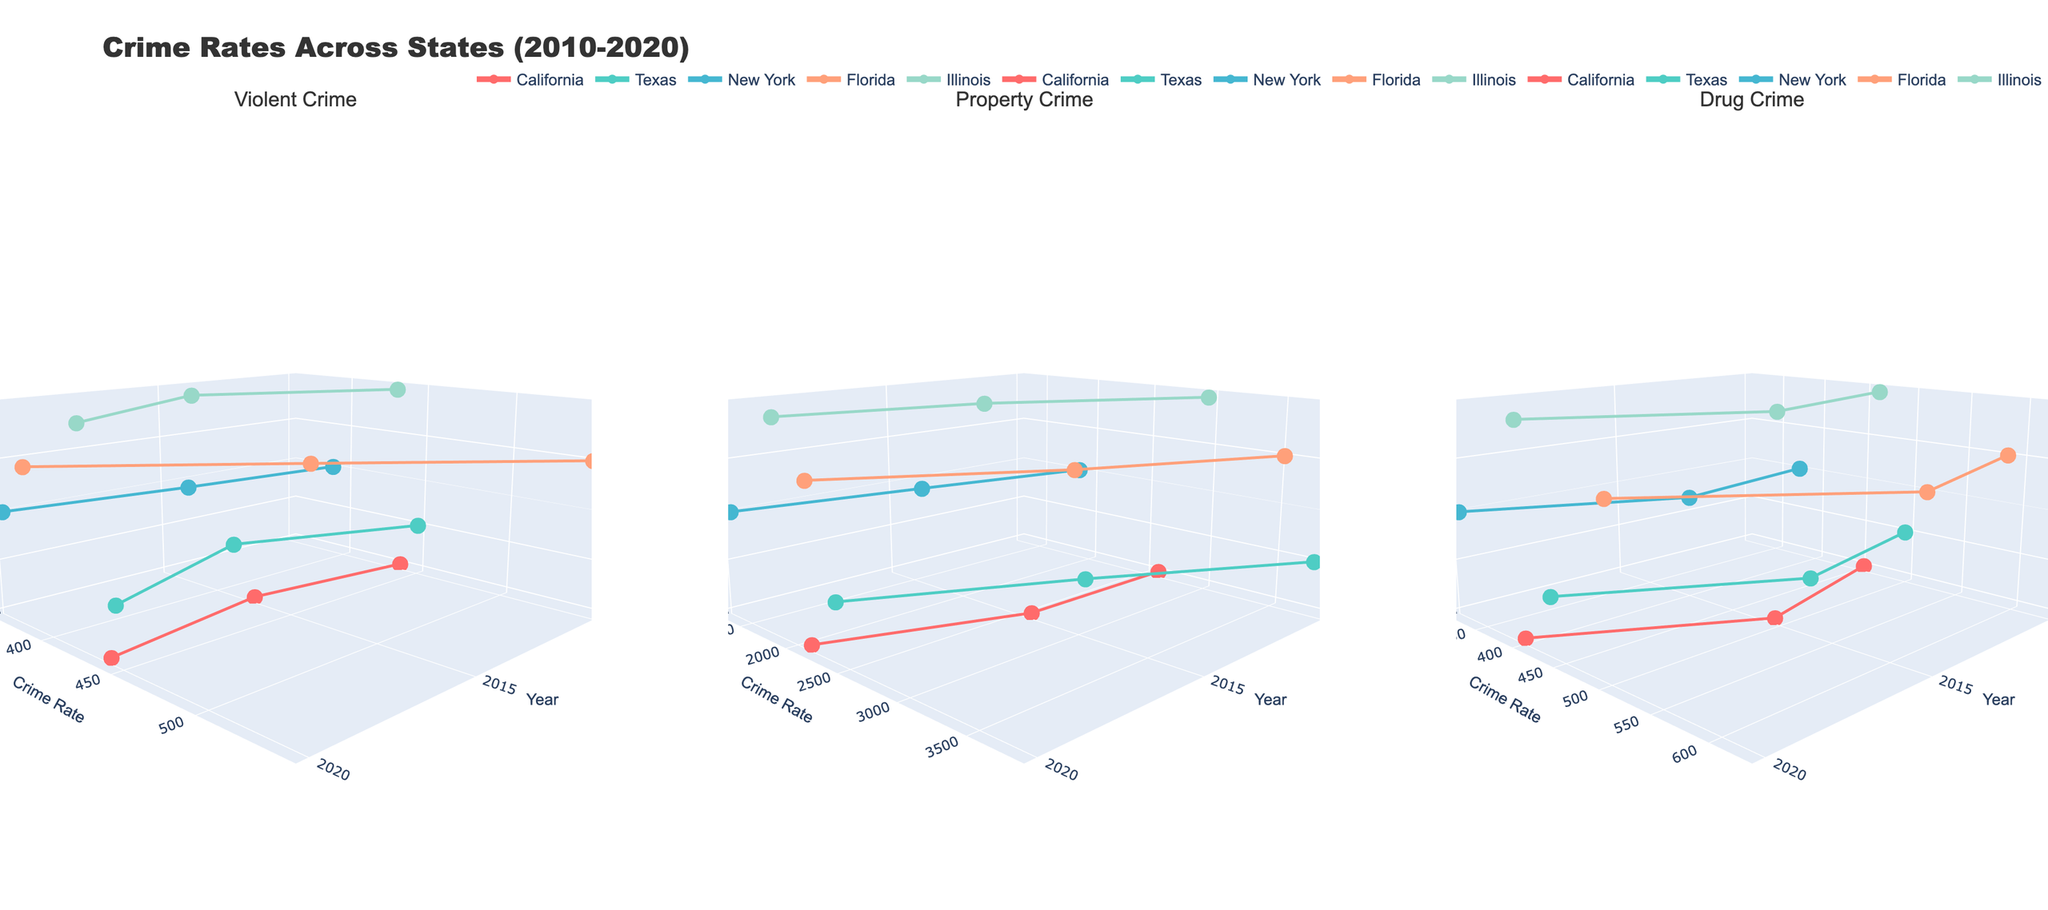What is the title of the figure? The title is usually found at the top of the plot and summarizes what the plot is about. In this case, it reads "Crime Rates Across States (2010-2020)".
Answer: Crime Rates Across States (2010-2020) How many different states are represented in the figure? The z-axis shows different states as categories. Reviewing the axis, you see "California," "Texas," "New York," "Florida," and "Illinois," totaling five distinct states.
Answer: Five Which state had the highest violent crime rate in 2010? Looking at the Violent Crime subplot for the year 2010, the state with the point positioned highest on the y-axis is Florida with a rate of 542.4.
Answer: Florida What is the trend in property crime rates for California from 2010 to 2020? By observing the Property Crime subplot for California, the y-coordinates for the points from years 2010, 2015, and 2020 indicate a continuous decline (2635.8 to 2620.4 to 2139.5).
Answer: Decreasing Which state saw the largest decrease in drug crime rates from 2015 to 2020? Reviewing the Drug Crime subplot, calculate the difference for each state between 2015 and 2020. Texas dropped from 528.9 to 435.1, a decrease of 93.8, the largest among all states.
Answer: Texas Between 2010 and 2020, did any state show an increase in both violent and property crime rates? Violent and Property Crime subplots examined state by state (increasing trends in y-coordinates). None of the states show simultaneous increases in both crime types; California has an overall increase in violent crime but a decrease in property crime rates.
Answer: No How do the crime rates in Texas and Florida compare in 2020 for violent crime? In the Violent Crime subplot for the year 2020, compare y-values for Texas (446.5) and Florida (383.6). Texas has a higher rate.
Answer: Texas has a higher rate What is the trend of drug crime rates in New York from 2010 to 2020? Check Drug Crime subplot for New York's y-coordinates, showing a downward trend from 379.5 (2010) to 401.2 (2015) and down further to 318.6 (2020).
Answer: Decreasing What is the average drug crime rate for Illinois over the years 2010, 2015, and 2020? Calculate average from the Drug Crime subplot: (467.8 + 495.6 + 401.7)/3 = 455
Answer: 455 Which state had the lowest property crime rate in 2020? In the Property Crime subplot for the year 2020, the lowest y-value belongs to New York, with a property crime rate of 1329.7.
Answer: New York 